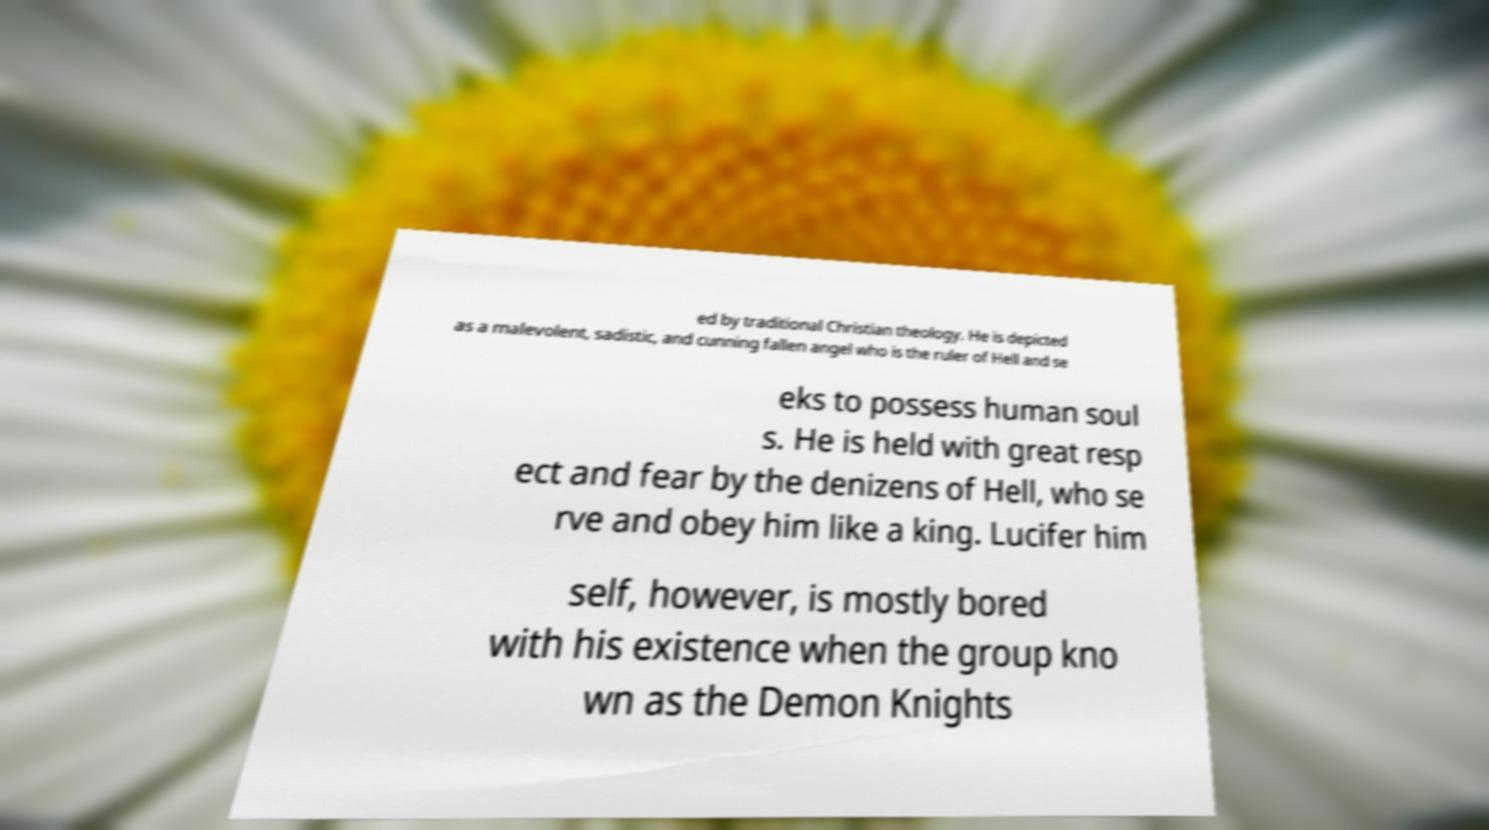What messages or text are displayed in this image? I need them in a readable, typed format. ed by traditional Christian theology. He is depicted as a malevolent, sadistic, and cunning fallen angel who is the ruler of Hell and se eks to possess human soul s. He is held with great resp ect and fear by the denizens of Hell, who se rve and obey him like a king. Lucifer him self, however, is mostly bored with his existence when the group kno wn as the Demon Knights 